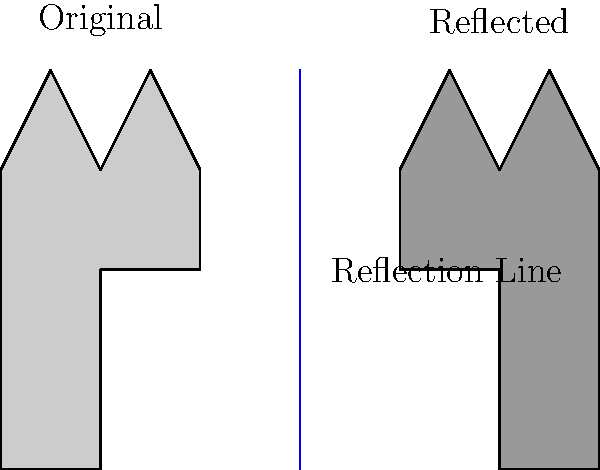The diagram shows a simplified outline of Windsor Castle reflected across a vertical line. If the highest point of the original castle is at coordinates (1.5, 4), what are the coordinates of the highest point of the reflected castle? Express your answer as an ordered pair (x, y). To find the coordinates of the highest point of the reflected castle, we need to follow these steps:

1. Identify the reflection line: The blue line in the diagram represents the reflection line. It is a vertical line passing through x = 3.

2. Locate the highest point of the original castle: As given in the question, this point is at (1.5, 4).

3. Apply the reflection transformation:
   - For a reflection across a vertical line x = a, the transformation is (x, y) → (2a - x, y).
   - In this case, a = 3 (the x-coordinate of the reflection line).

4. Calculate the new x-coordinate:
   x' = 2a - x = 2(3) - 1.5 = 6 - 1.5 = 4.5

5. The y-coordinate remains unchanged in a reflection across a vertical line.

Therefore, the coordinates of the highest point of the reflected castle are (4.5, 4).

This reflection illustrates the principle of bilateral symmetry often found in castle architecture, where one half of the structure mirrors the other, creating a balanced and imposing appearance.
Answer: (4.5, 4) 